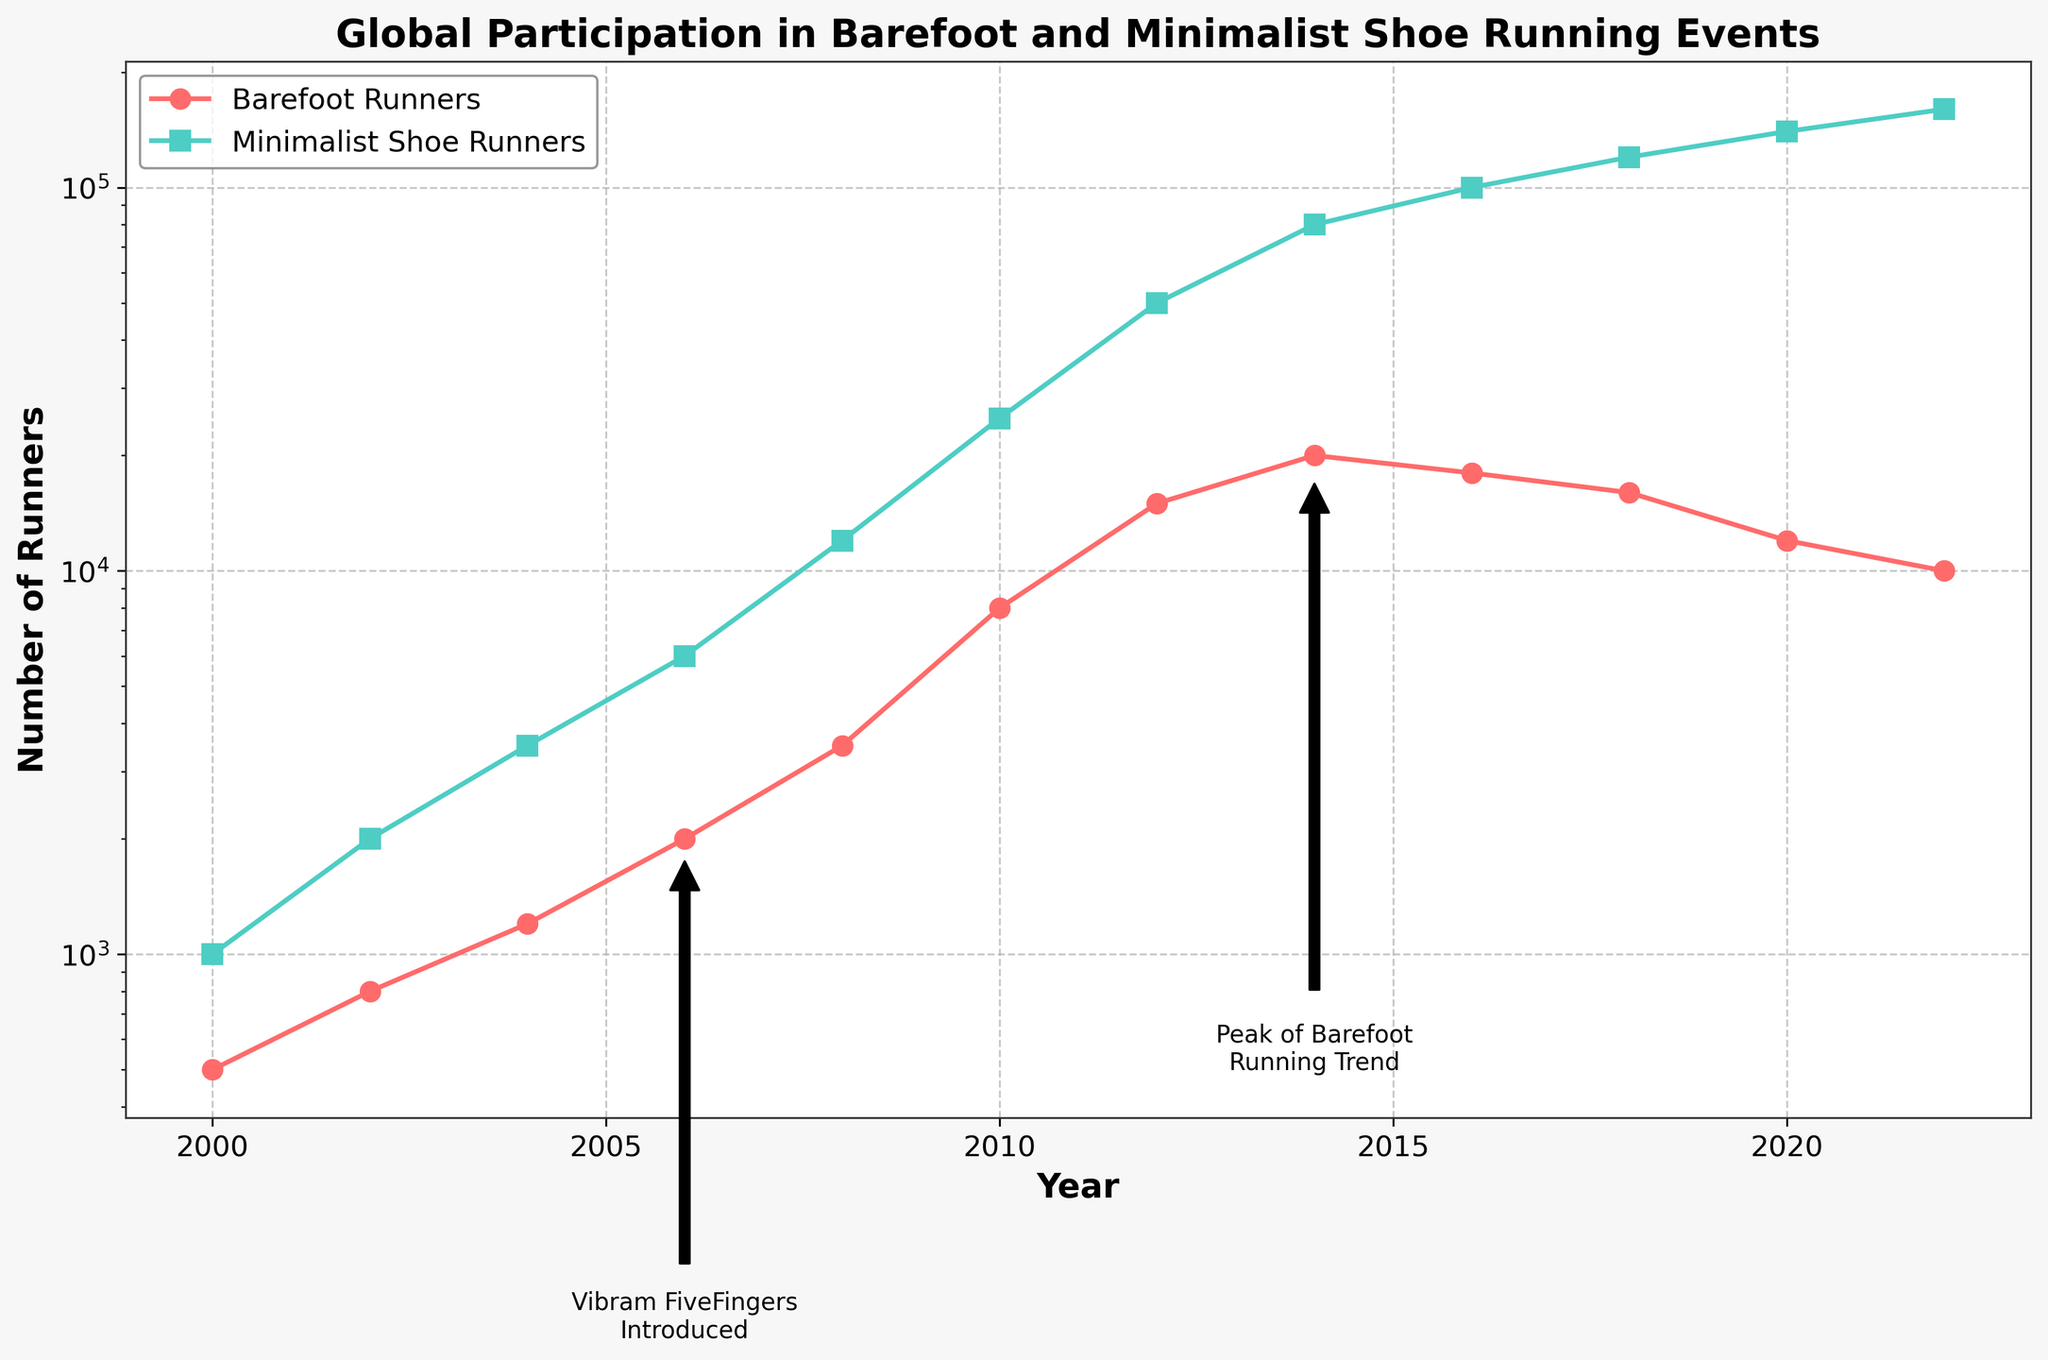What year did barefoot runners peak? The figure shows an annotation "Peak of Barefoot Running Trend" at the year 2014, which indicates the peak number of barefoot runners at 20,000.
Answer: 2014 What was the total number of participants in 2016? To find this, you need to refer to the "Total Participants" line for the year 2016, which indicates 118,000.
Answer: 118,000 Between which years did barefoot running see the largest increase? Compare the year-on-year increase for barefoot runners between each pair of consecutive years. The largest increase is from 2008 to 2010, from 3,500 to 8,000, which is an increase of 4,500.
Answer: 2008-2010 In 2010, were there more barefoot runners or minimalist shoe runners? Look at the values in 2010 for both categories. Minimalist shoe runners had 25,000 participants whereas barefoot runners had 8,000 participants.
Answer: Minimalist shoe runners How does the trend of barefoot runners compare to minimalist shoe runners from 2000 to 2022? The number of minimalist shoe runners increased more consistently and drastically than barefoot runners, peaking at 160,000 in 2022, whereas barefoot runners peaked in 2014 and then declined.
Answer: Minimalist shoe runners show a more consistent and larger increase than barefoot runners What two annotations are displayed in the figure, and what events do they highlight? The figure has annotations for "Vibram FiveFingers Introduced" in 2006 and "Peak of Barefoot Running Trend" in 2014. These mark the year Vibram FiveFingers were introduced and the peak trend year for barefoot running.
Answer: Vibram FiveFingers Introduced and Peak of Barefoot Running Trend Which color represents the minimalist shoe runners in the chart? The figure uses visual attributes, showing minimalist shoe runners displayed with a green line.
Answer: Green How does the number of barefoot runners in 2022 compare to 2000? The number of barefoot runners in 2022 is 10,000, whereas it was 500 in 2000, indicating a significant increase by 9,500 runners.
Answer: 10,000 versus 500 If you average the number of barefoot runners from 2000 to 2022, what is the result? Calculate the sum of barefoot runners over all years (500 + 800 + 1200 + 2000 + 3500 + 8000 + 15000 + 20000 + 18000 + 16000 + 12000 + 10000 = 110000) and divide by the number of years (12). The average is 110000/12 = 9166.67.
Answer: 9166.67 Between 2018 and 2020, did the number of barefoot runners or minimalist shoe runners decrease more significantly? The number of barefoot runners decreased from 16,000 to 12,000, a decrease of 4,000. Minimalist shoe runners increased during the same period.
Answer: Barefoot runners 